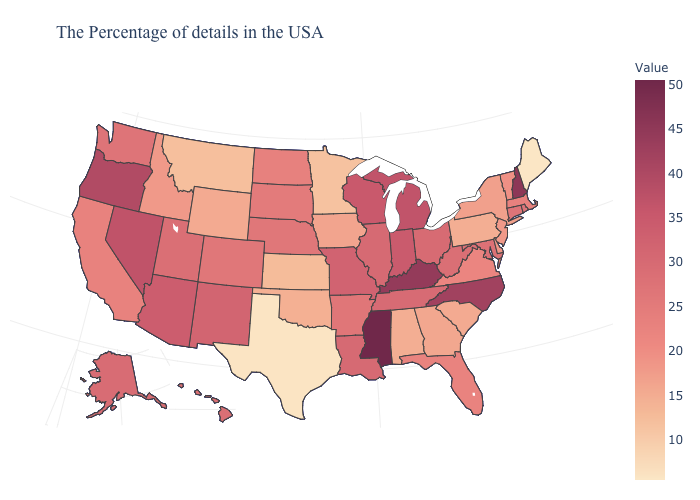Does the map have missing data?
Concise answer only. No. Does Oregon have the highest value in the West?
Be succinct. Yes. Does North Carolina have the highest value in the South?
Answer briefly. No. Which states have the lowest value in the USA?
Give a very brief answer. Maine. Does Texas have the lowest value in the South?
Short answer required. Yes. Which states have the lowest value in the Northeast?
Concise answer only. Maine. Does Texas have the lowest value in the South?
Write a very short answer. Yes. Which states have the lowest value in the West?
Be succinct. Montana. Does Maine have the lowest value in the USA?
Keep it brief. Yes. 